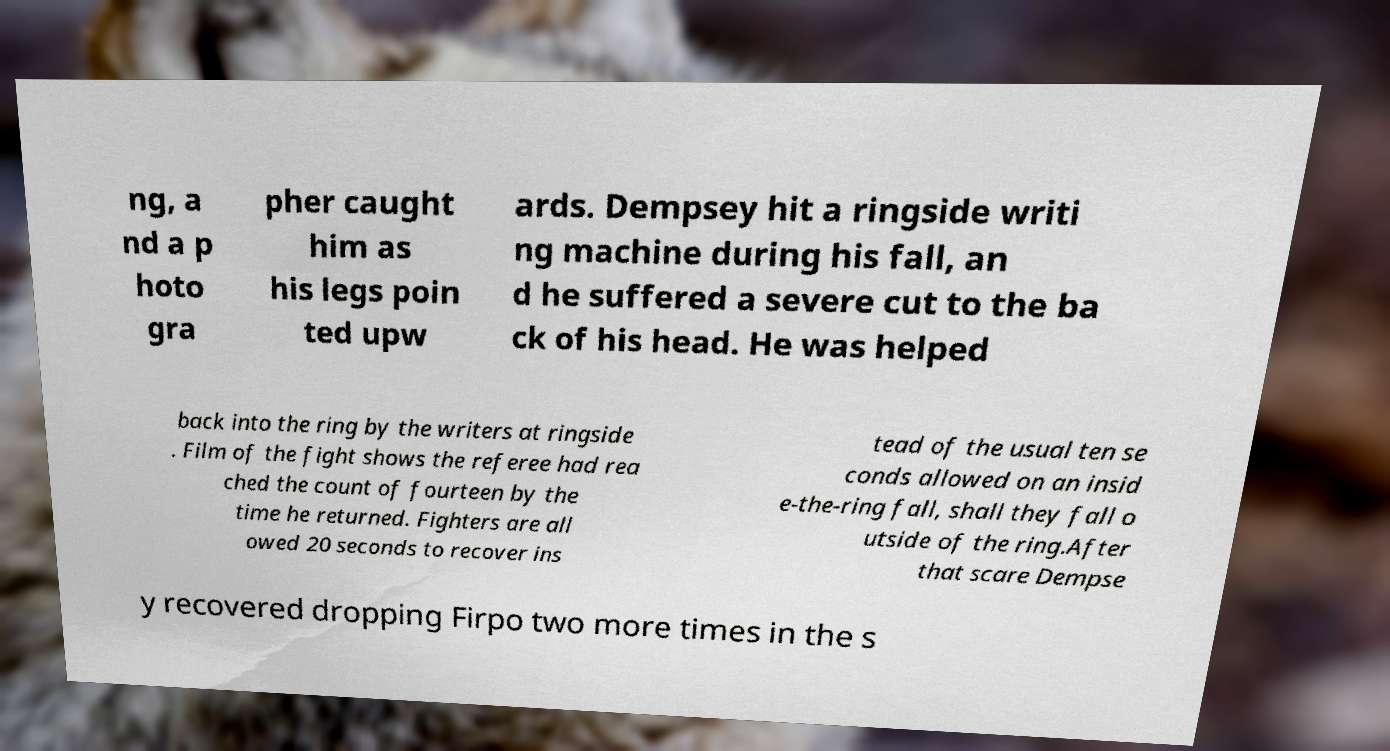For documentation purposes, I need the text within this image transcribed. Could you provide that? ng, a nd a p hoto gra pher caught him as his legs poin ted upw ards. Dempsey hit a ringside writi ng machine during his fall, an d he suffered a severe cut to the ba ck of his head. He was helped back into the ring by the writers at ringside . Film of the fight shows the referee had rea ched the count of fourteen by the time he returned. Fighters are all owed 20 seconds to recover ins tead of the usual ten se conds allowed on an insid e-the-ring fall, shall they fall o utside of the ring.After that scare Dempse y recovered dropping Firpo two more times in the s 